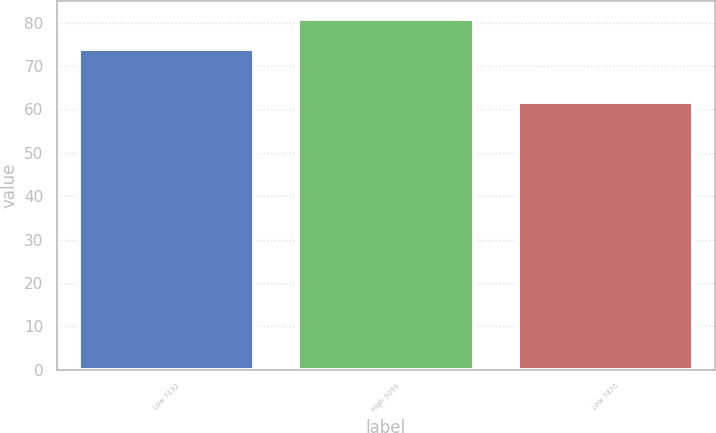<chart> <loc_0><loc_0><loc_500><loc_500><bar_chart><fcel>Low 7192<fcel>High 9099<fcel>Low 7470<nl><fcel>73.81<fcel>80.82<fcel>61.72<nl></chart> 